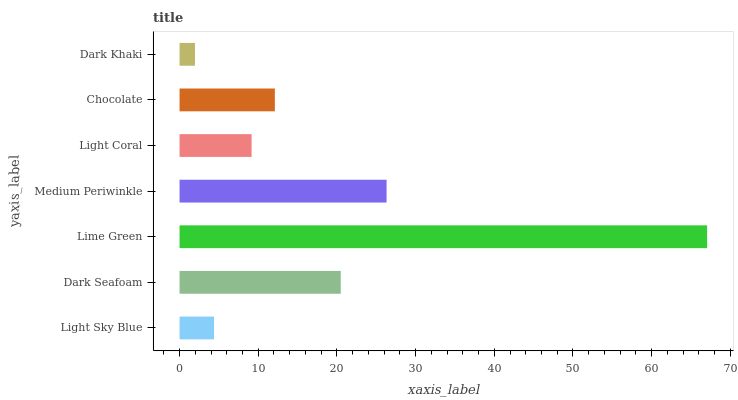Is Dark Khaki the minimum?
Answer yes or no. Yes. Is Lime Green the maximum?
Answer yes or no. Yes. Is Dark Seafoam the minimum?
Answer yes or no. No. Is Dark Seafoam the maximum?
Answer yes or no. No. Is Dark Seafoam greater than Light Sky Blue?
Answer yes or no. Yes. Is Light Sky Blue less than Dark Seafoam?
Answer yes or no. Yes. Is Light Sky Blue greater than Dark Seafoam?
Answer yes or no. No. Is Dark Seafoam less than Light Sky Blue?
Answer yes or no. No. Is Chocolate the high median?
Answer yes or no. Yes. Is Chocolate the low median?
Answer yes or no. Yes. Is Light Coral the high median?
Answer yes or no. No. Is Light Coral the low median?
Answer yes or no. No. 